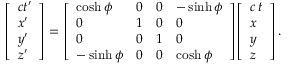Convert formula to latex. <formula><loc_0><loc_0><loc_500><loc_500>{ \left [ \begin{array} { l } { c t ^ { \prime } } \\ { x ^ { \prime } } \\ { y ^ { \prime } } \\ { z ^ { \prime } } \end{array} \right ] } = { \left [ \begin{array} { l l l l } { \cosh \phi } & { 0 } & { 0 } & { - \sinh \phi } \\ { 0 } & { 1 } & { 0 } & { 0 } \\ { 0 } & { 0 } & { 1 } & { 0 } \\ { - \sinh \phi } & { 0 } & { 0 } & { \cosh \phi } \end{array} \right ] } { \left [ \begin{array} { l } { c \, t } \\ { x } \\ { y } \\ { z } \end{array} \right ] } \, .</formula> 